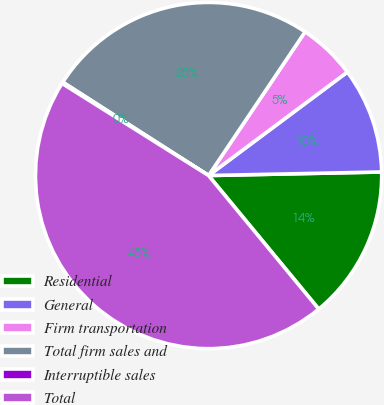<chart> <loc_0><loc_0><loc_500><loc_500><pie_chart><fcel>Residential<fcel>General<fcel>Firm transportation<fcel>Total firm sales and<fcel>Interruptible sales<fcel>Total<nl><fcel>14.35%<fcel>9.87%<fcel>5.39%<fcel>25.35%<fcel>0.13%<fcel>44.91%<nl></chart> 